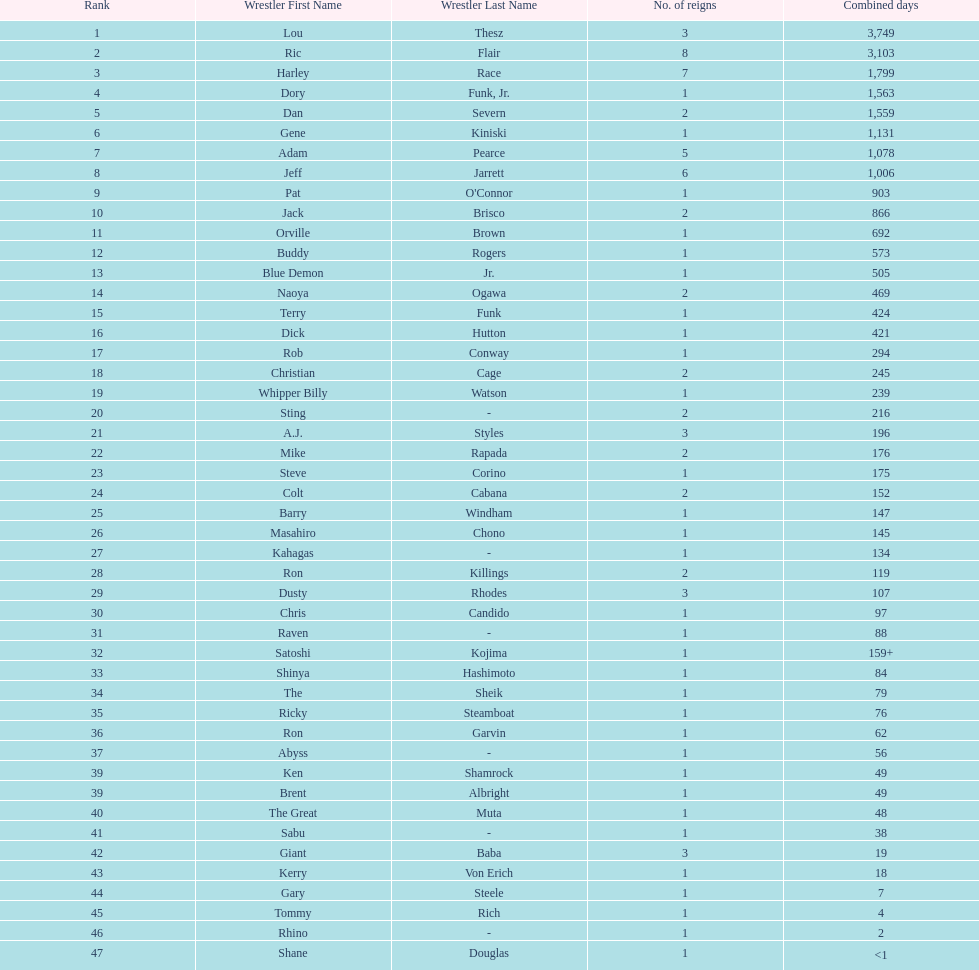Who has spent more time as nwa world heavyyweight champion, gene kiniski or ric flair? Ric Flair. 